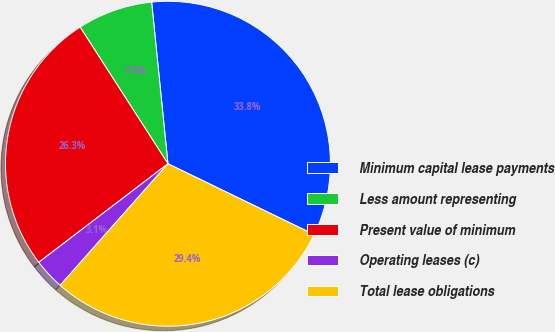<chart> <loc_0><loc_0><loc_500><loc_500><pie_chart><fcel>Minimum capital lease payments<fcel>Less amount representing<fcel>Present value of minimum<fcel>Operating leases (c)<fcel>Total lease obligations<nl><fcel>33.78%<fcel>7.49%<fcel>26.28%<fcel>3.08%<fcel>29.36%<nl></chart> 